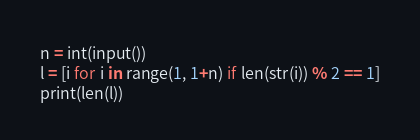<code> <loc_0><loc_0><loc_500><loc_500><_Python_>n = int(input())
l = [i for i in range(1, 1+n) if len(str(i)) % 2 == 1]
print(len(l))</code> 